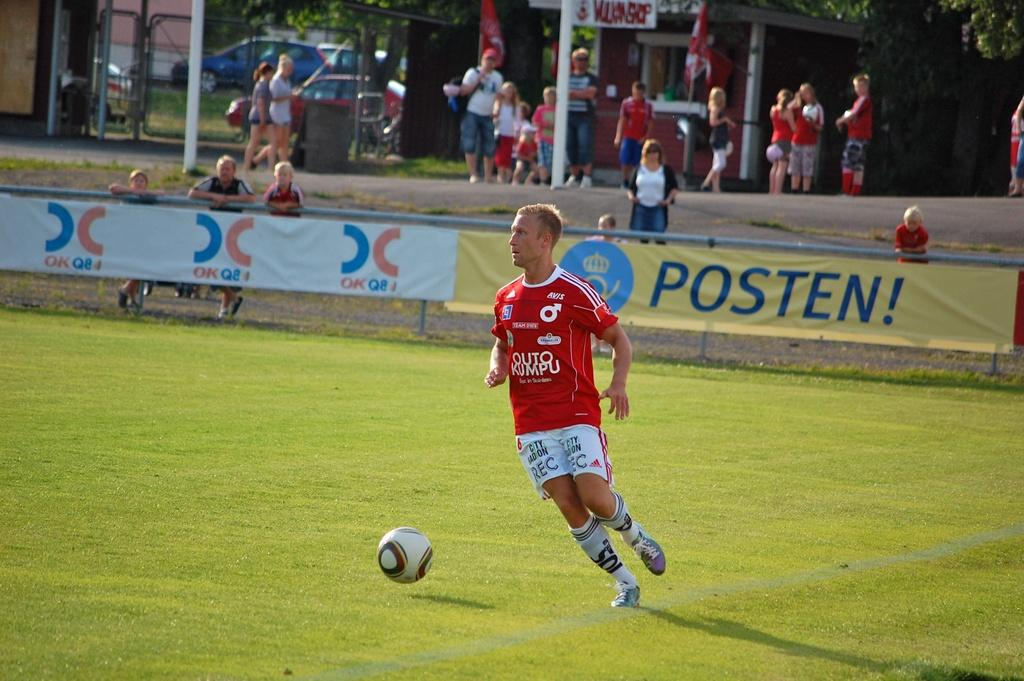<image>
Present a compact description of the photo's key features. A player for the Outo Kumpu soccer team dribbles the ball. 